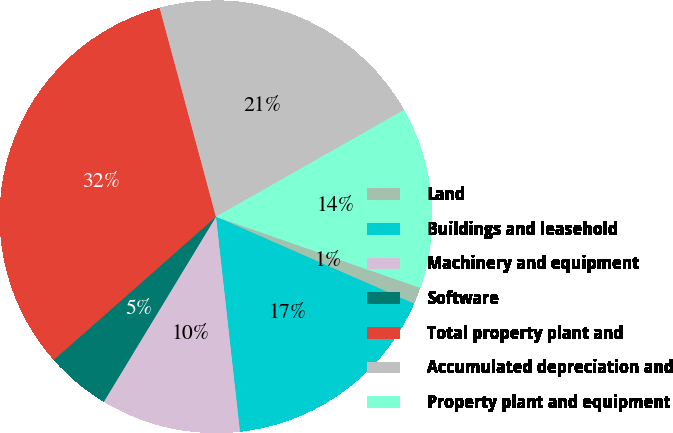Convert chart to OTSL. <chart><loc_0><loc_0><loc_500><loc_500><pie_chart><fcel>Land<fcel>Buildings and leasehold<fcel>Machinery and equipment<fcel>Software<fcel>Total property plant and<fcel>Accumulated depreciation and<fcel>Property plant and equipment<nl><fcel>1.25%<fcel>16.65%<fcel>10.44%<fcel>4.82%<fcel>32.32%<fcel>20.97%<fcel>13.55%<nl></chart> 